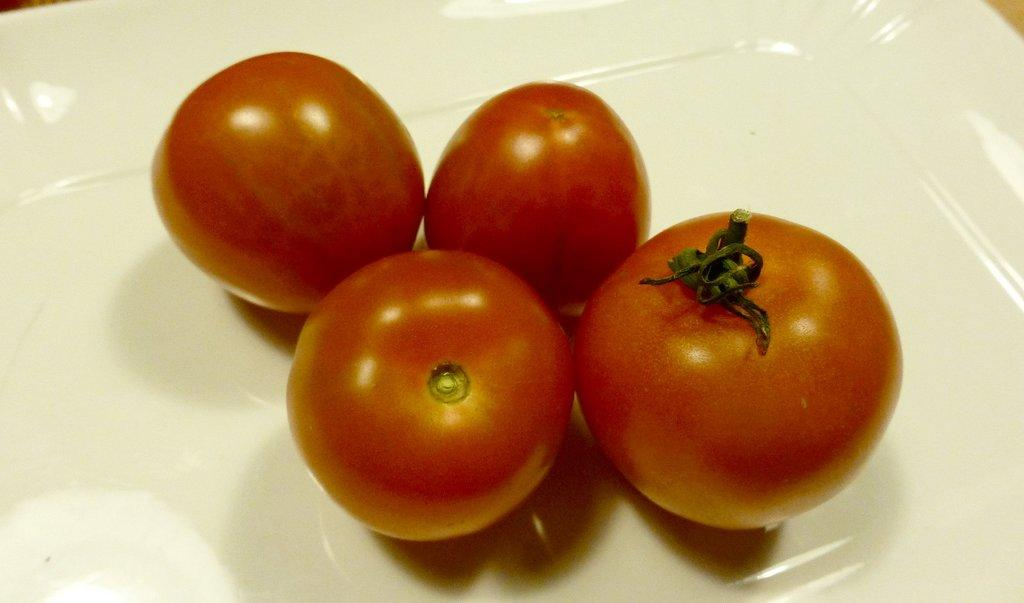How many tomatoes are visible in the image? There are four tomatoes in the image. What is the color of the plate on which the tomatoes are placed? The tomatoes are on a white color plate. What type of pancake is being used as fuel for the car in the image? There is no car or pancake present in the image; it features four tomatoes on a white color plate. 